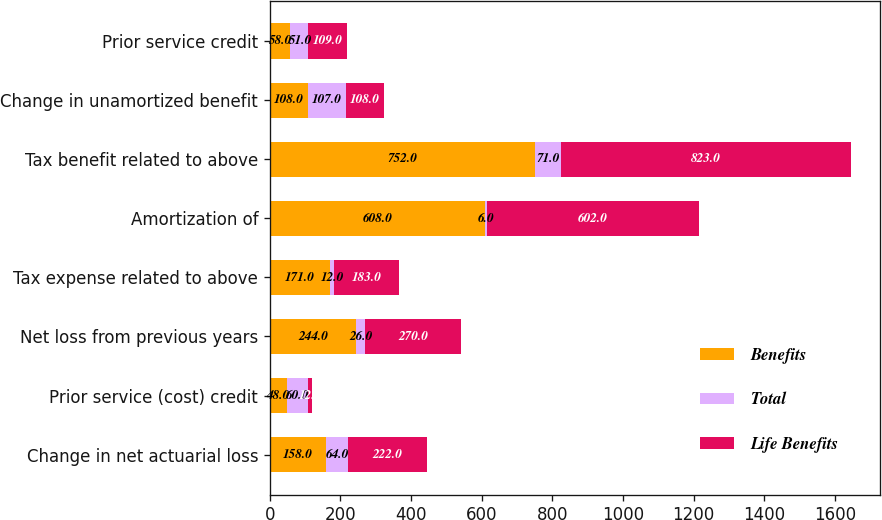<chart> <loc_0><loc_0><loc_500><loc_500><stacked_bar_chart><ecel><fcel>Change in net actuarial loss<fcel>Prior service (cost) credit<fcel>Net loss from previous years<fcel>Tax expense related to above<fcel>Amortization of<fcel>Tax benefit related to above<fcel>Change in unamortized benefit<fcel>Prior service credit<nl><fcel>Benefits<fcel>158<fcel>48<fcel>244<fcel>171<fcel>608<fcel>752<fcel>108<fcel>58<nl><fcel>Total<fcel>64<fcel>60<fcel>26<fcel>12<fcel>6<fcel>71<fcel>107<fcel>51<nl><fcel>Life Benefits<fcel>222<fcel>12<fcel>270<fcel>183<fcel>602<fcel>823<fcel>108<fcel>109<nl></chart> 